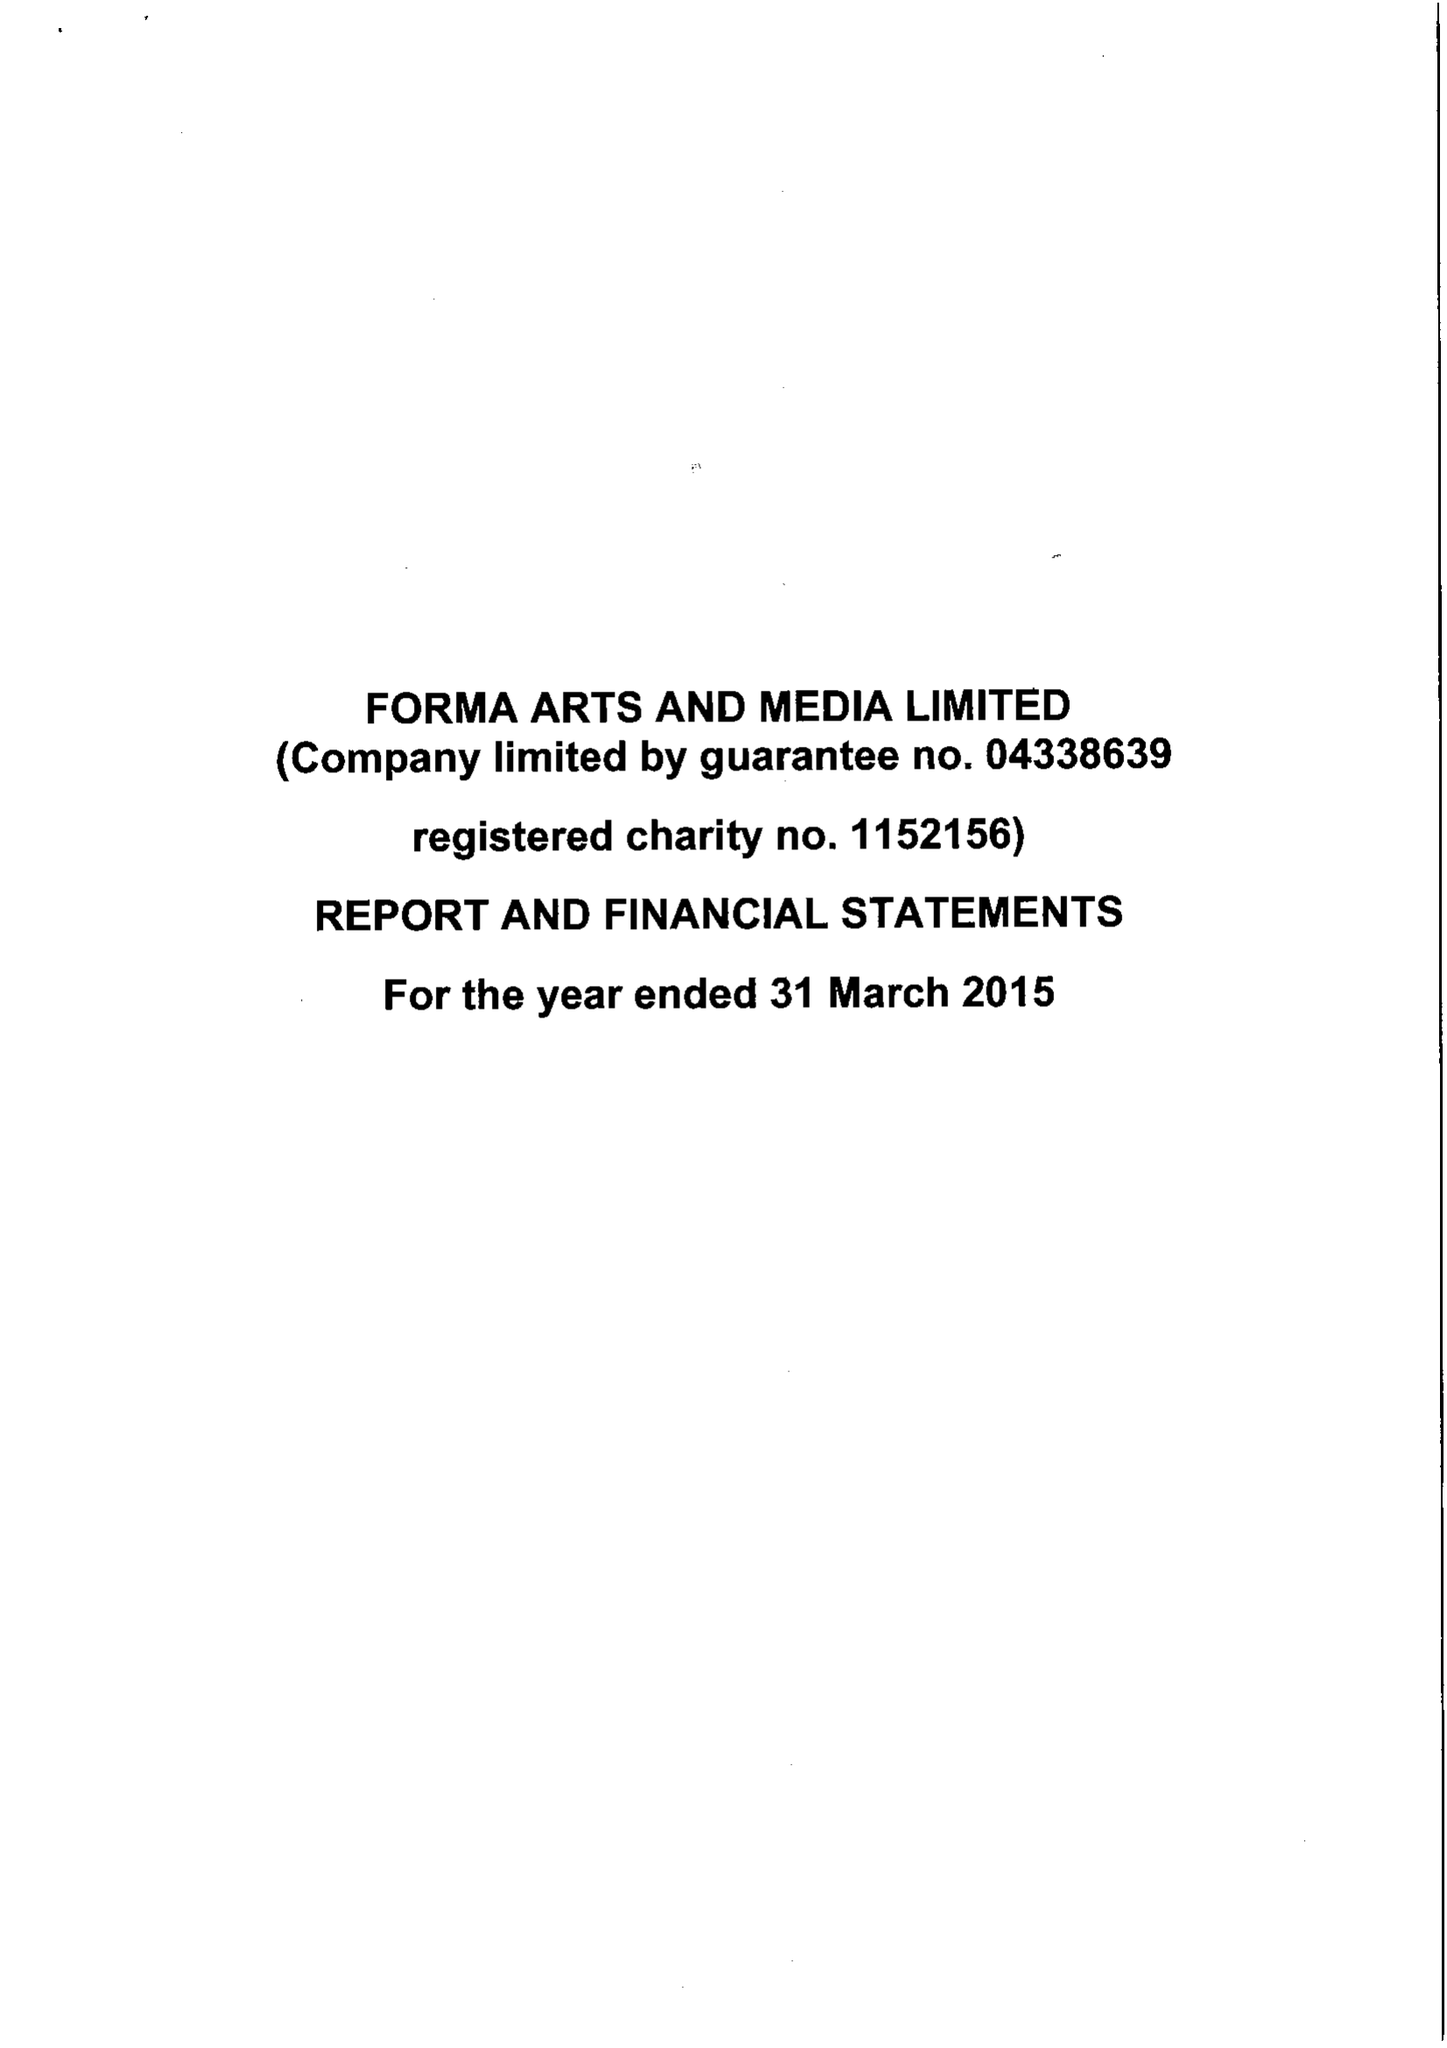What is the value for the income_annually_in_british_pounds?
Answer the question using a single word or phrase. 600184.00 